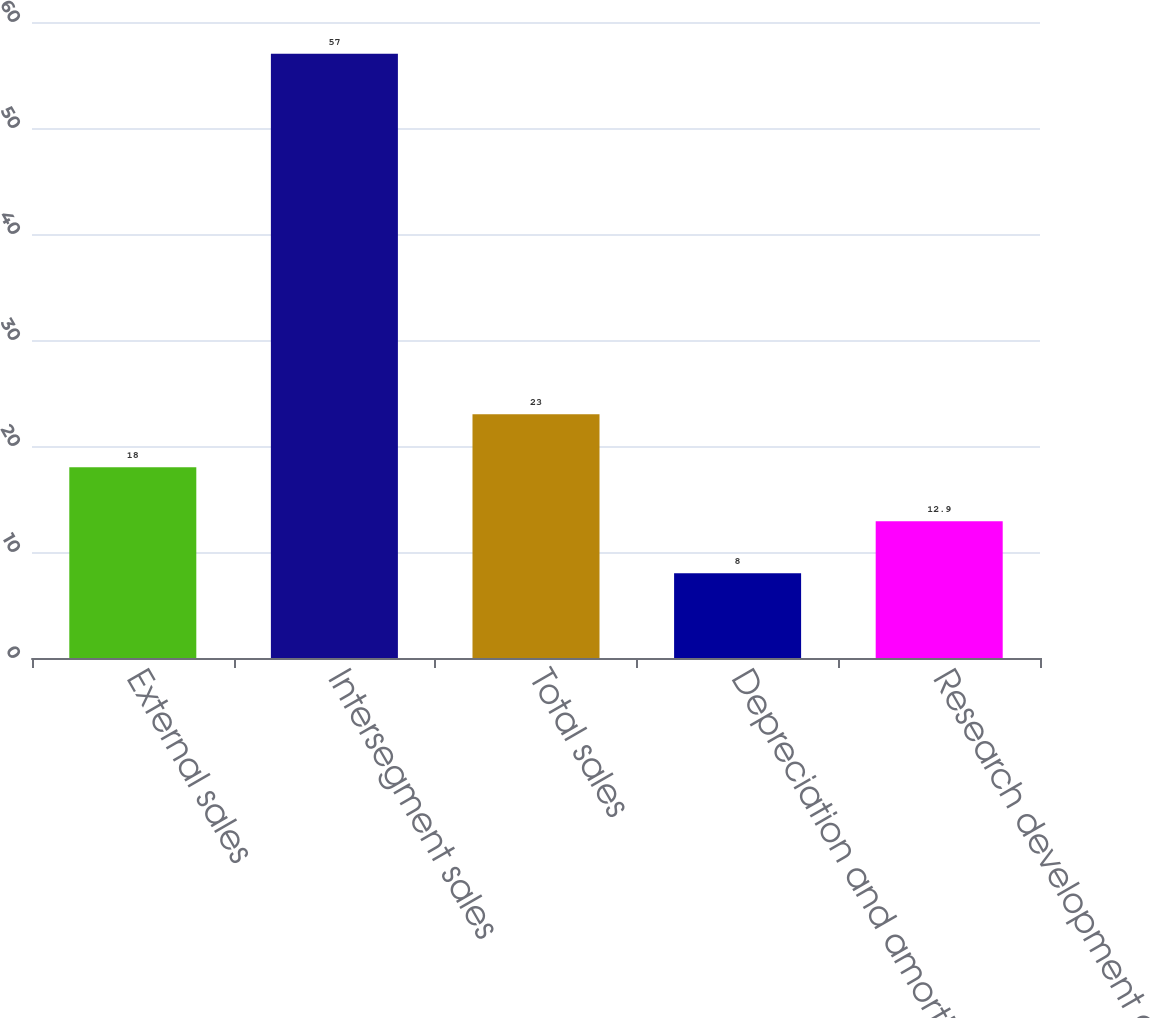<chart> <loc_0><loc_0><loc_500><loc_500><bar_chart><fcel>External sales<fcel>Intersegment sales<fcel>Total sales<fcel>Depreciation and amortization<fcel>Research development and<nl><fcel>18<fcel>57<fcel>23<fcel>8<fcel>12.9<nl></chart> 